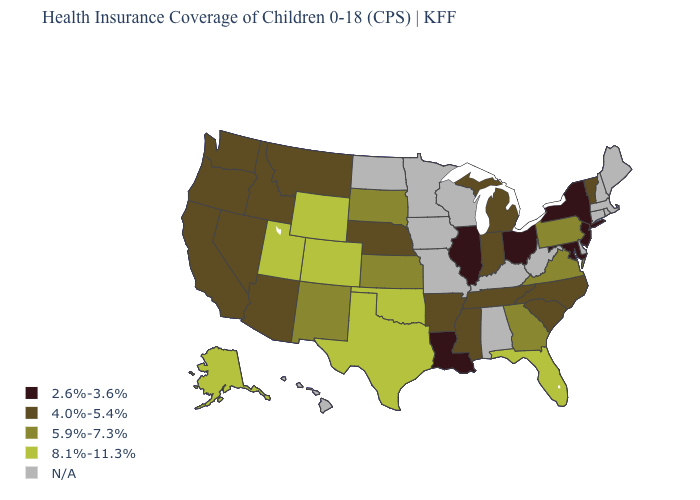Name the states that have a value in the range 5.9%-7.3%?
Answer briefly. Georgia, Kansas, New Mexico, Pennsylvania, South Dakota, Virginia. What is the value of Indiana?
Give a very brief answer. 4.0%-5.4%. Name the states that have a value in the range N/A?
Keep it brief. Alabama, Connecticut, Delaware, Hawaii, Iowa, Kentucky, Maine, Massachusetts, Minnesota, Missouri, New Hampshire, North Dakota, Rhode Island, West Virginia, Wisconsin. How many symbols are there in the legend?
Short answer required. 5. Does Virginia have the lowest value in the USA?
Write a very short answer. No. Does the first symbol in the legend represent the smallest category?
Be succinct. Yes. Name the states that have a value in the range 2.6%-3.6%?
Short answer required. Illinois, Louisiana, Maryland, New Jersey, New York, Ohio. What is the lowest value in the Northeast?
Short answer required. 2.6%-3.6%. Name the states that have a value in the range 8.1%-11.3%?
Keep it brief. Alaska, Colorado, Florida, Oklahoma, Texas, Utah, Wyoming. Which states hav the highest value in the West?
Be succinct. Alaska, Colorado, Utah, Wyoming. Among the states that border Connecticut , which have the highest value?
Give a very brief answer. New York. Is the legend a continuous bar?
Short answer required. No. Does Pennsylvania have the lowest value in the Northeast?
Give a very brief answer. No. Name the states that have a value in the range 5.9%-7.3%?
Write a very short answer. Georgia, Kansas, New Mexico, Pennsylvania, South Dakota, Virginia. 